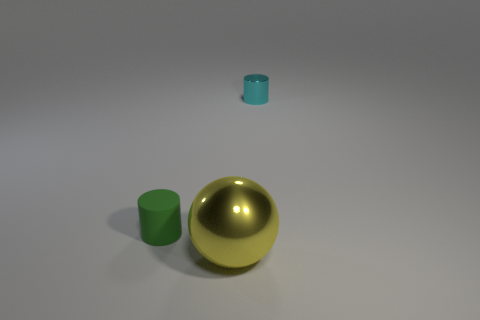Add 3 small green objects. How many objects exist? 6 Subtract all spheres. How many objects are left? 2 Add 3 small cyan matte blocks. How many small cyan matte blocks exist? 3 Subtract 0 brown balls. How many objects are left? 3 Subtract all small blue rubber balls. Subtract all small green cylinders. How many objects are left? 2 Add 3 yellow shiny spheres. How many yellow shiny spheres are left? 4 